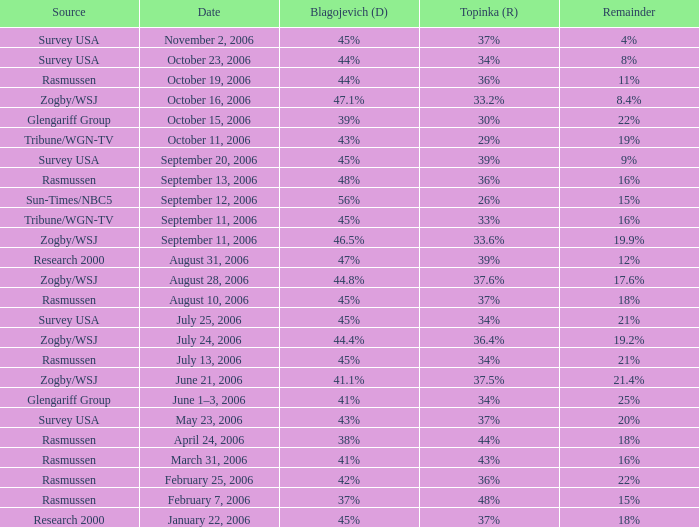Which Blagojevich (D) has a Source of zogby/wsj, and a Date of october 16, 2006? 47.1%. 